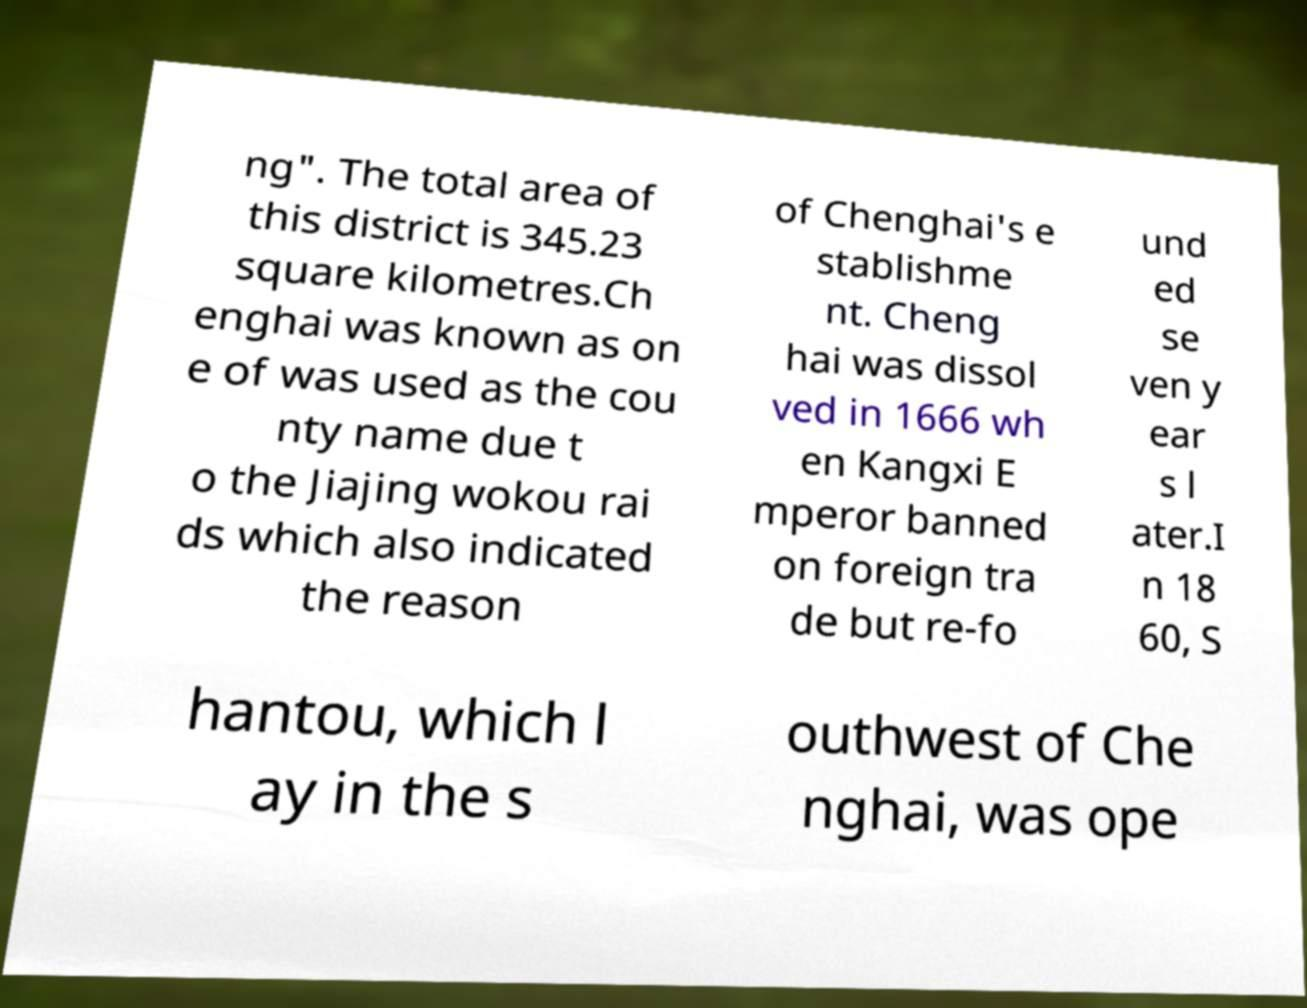Could you assist in decoding the text presented in this image and type it out clearly? ng". The total area of this district is 345.23 square kilometres.Ch enghai was known as on e of was used as the cou nty name due t o the Jiajing wokou rai ds which also indicated the reason of Chenghai's e stablishme nt. Cheng hai was dissol ved in 1666 wh en Kangxi E mperor banned on foreign tra de but re-fo und ed se ven y ear s l ater.I n 18 60, S hantou, which l ay in the s outhwest of Che nghai, was ope 